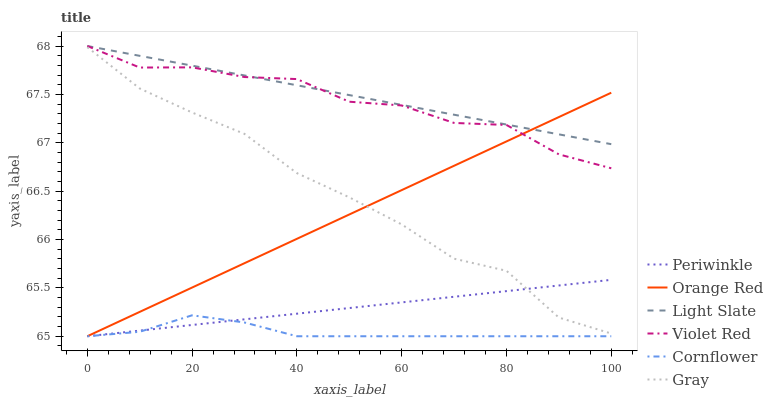Does Cornflower have the minimum area under the curve?
Answer yes or no. Yes. Does Light Slate have the maximum area under the curve?
Answer yes or no. Yes. Does Violet Red have the minimum area under the curve?
Answer yes or no. No. Does Violet Red have the maximum area under the curve?
Answer yes or no. No. Is Light Slate the smoothest?
Answer yes or no. Yes. Is Violet Red the roughest?
Answer yes or no. Yes. Is Gray the smoothest?
Answer yes or no. No. Is Gray the roughest?
Answer yes or no. No. Does Cornflower have the lowest value?
Answer yes or no. Yes. Does Violet Red have the lowest value?
Answer yes or no. No. Does Light Slate have the highest value?
Answer yes or no. Yes. Does Gray have the highest value?
Answer yes or no. No. Is Gray less than Violet Red?
Answer yes or no. Yes. Is Light Slate greater than Cornflower?
Answer yes or no. Yes. Does Periwinkle intersect Cornflower?
Answer yes or no. Yes. Is Periwinkle less than Cornflower?
Answer yes or no. No. Is Periwinkle greater than Cornflower?
Answer yes or no. No. Does Gray intersect Violet Red?
Answer yes or no. No. 